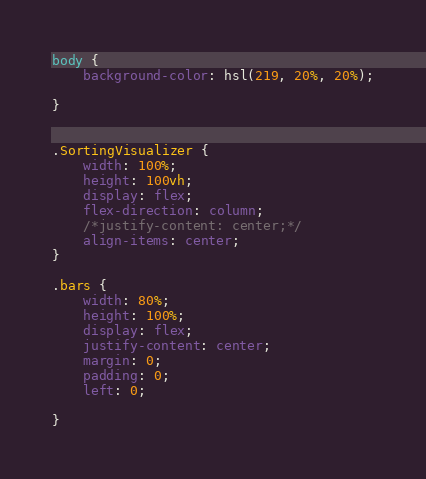<code> <loc_0><loc_0><loc_500><loc_500><_CSS_>body {
    background-color: hsl(219, 20%, 20%);

}


.SortingVisualizer {
    width: 100%;
    height: 100vh;
    display: flex;
    flex-direction: column;
    /*justify-content: center;*/
    align-items: center;
}

.bars {
    width: 80%;
    height: 100%;
    display: flex;
    justify-content: center;
    margin: 0;
    padding: 0;
    left: 0;

}</code> 